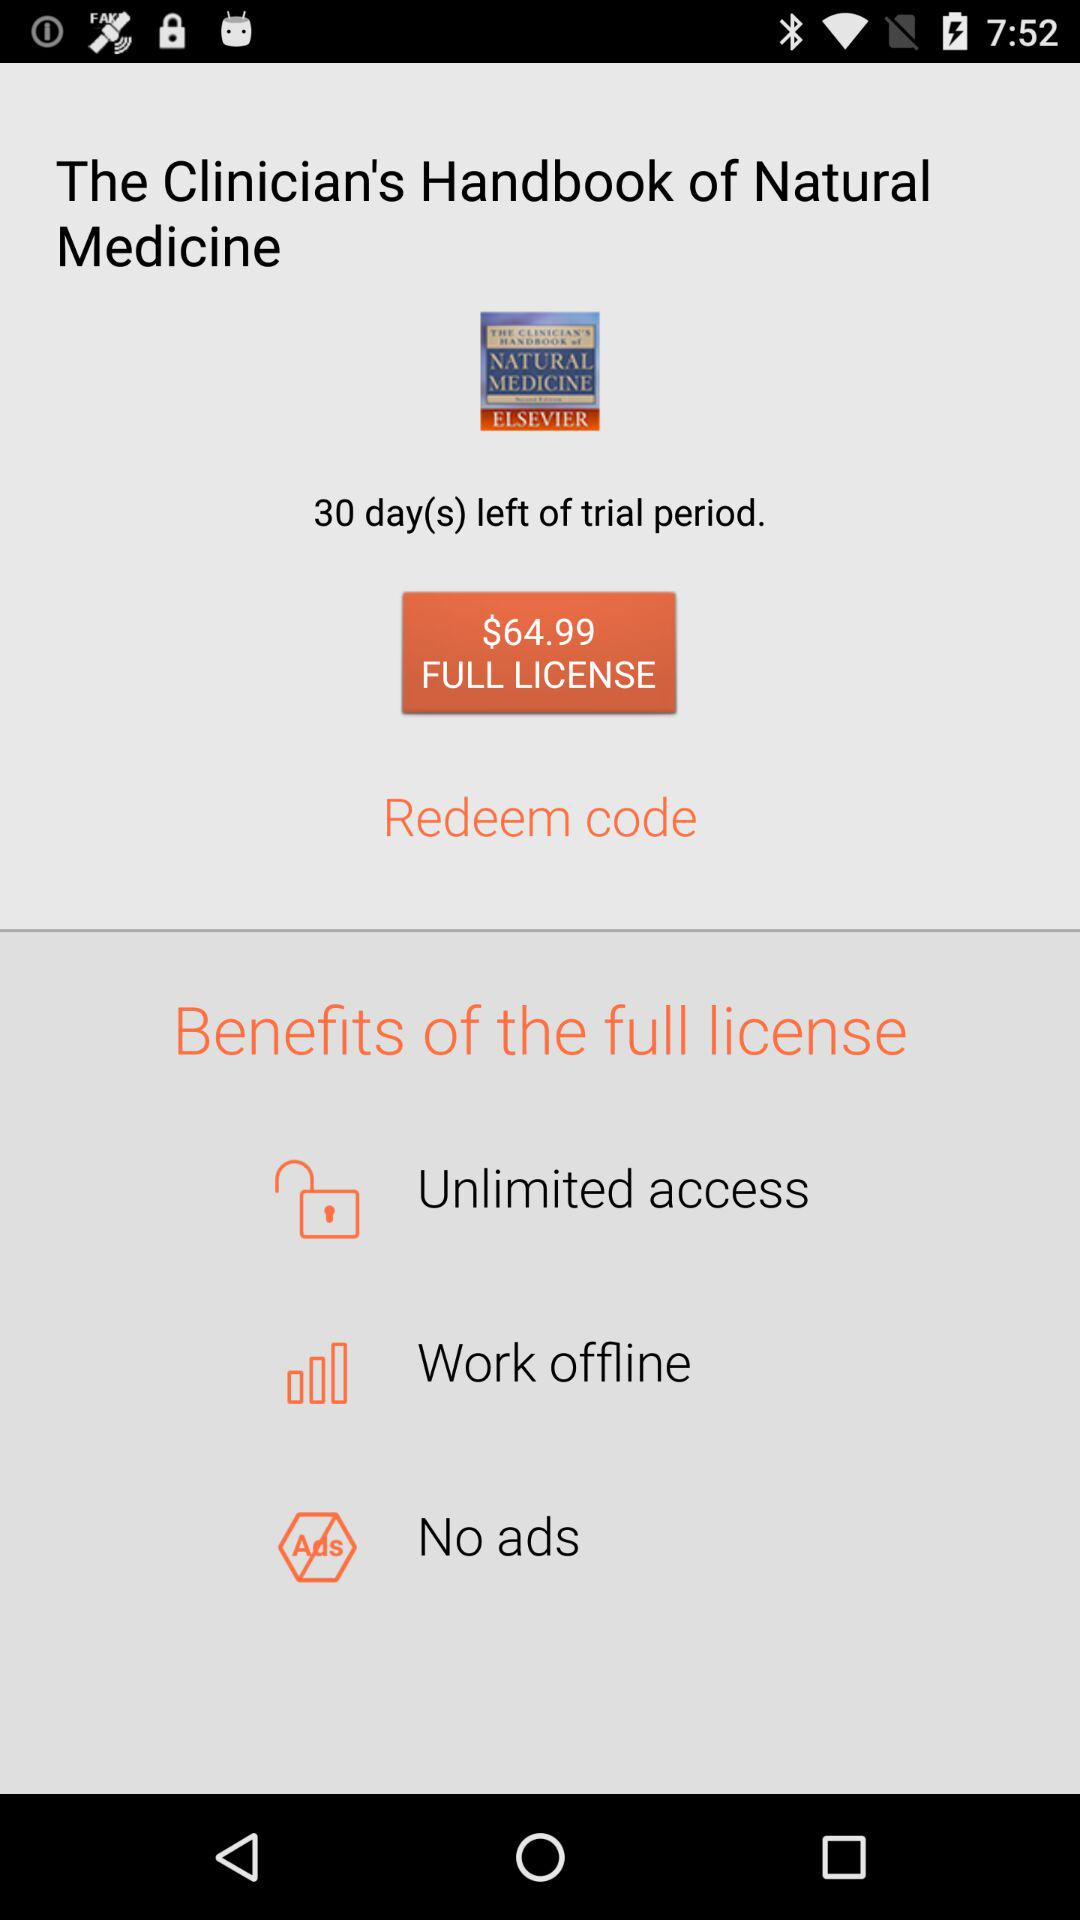What are the benefits of the full license? The benefits of the full license are unlimited access, work offline and no ads. 